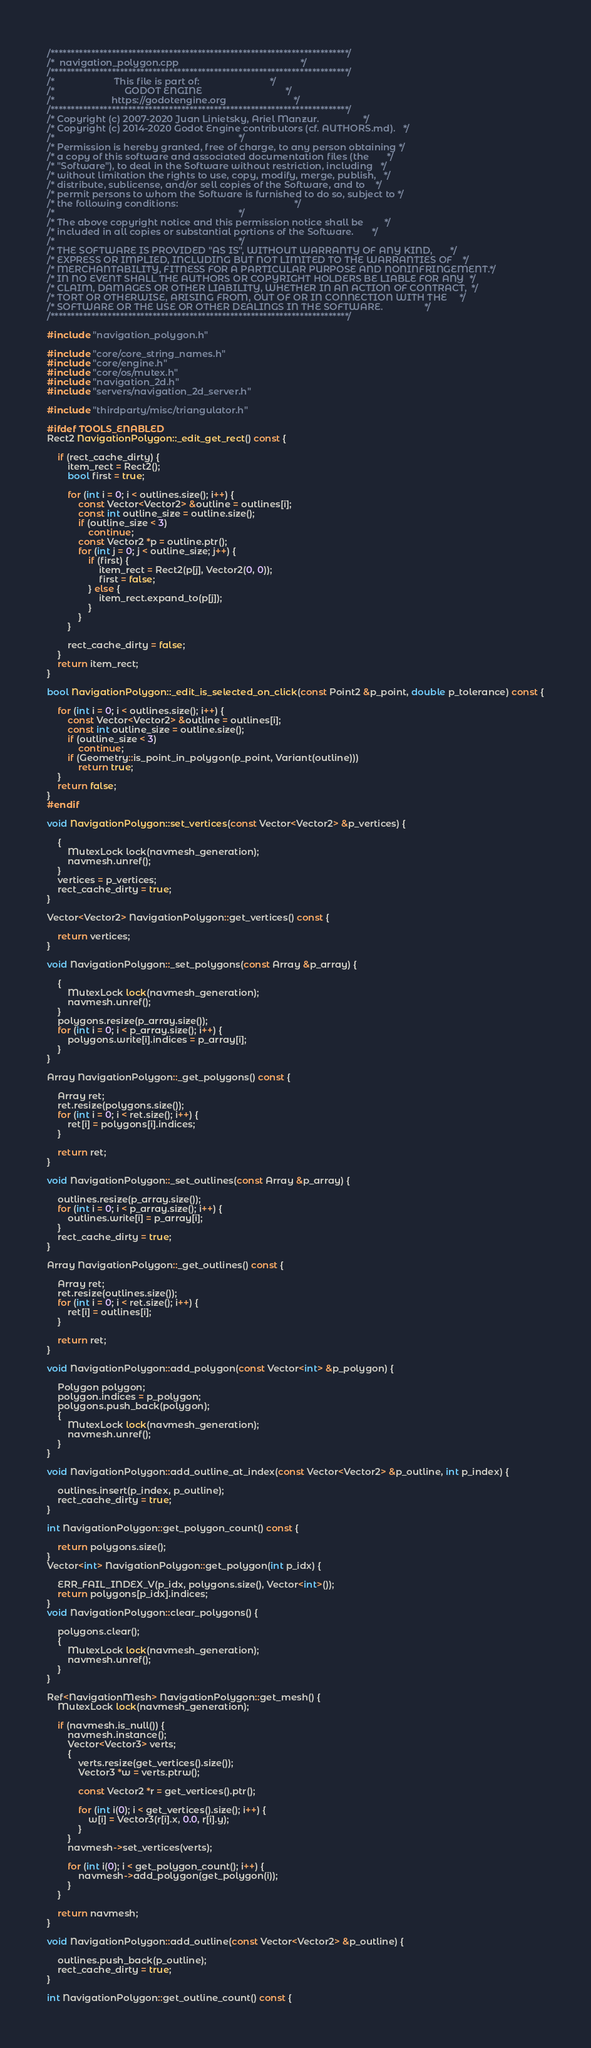<code> <loc_0><loc_0><loc_500><loc_500><_C++_>/*************************************************************************/
/*  navigation_polygon.cpp                                               */
/*************************************************************************/
/*                       This file is part of:                           */
/*                           GODOT ENGINE                                */
/*                      https://godotengine.org                          */
/*************************************************************************/
/* Copyright (c) 2007-2020 Juan Linietsky, Ariel Manzur.                 */
/* Copyright (c) 2014-2020 Godot Engine contributors (cf. AUTHORS.md).   */
/*                                                                       */
/* Permission is hereby granted, free of charge, to any person obtaining */
/* a copy of this software and associated documentation files (the       */
/* "Software"), to deal in the Software without restriction, including   */
/* without limitation the rights to use, copy, modify, merge, publish,   */
/* distribute, sublicense, and/or sell copies of the Software, and to    */
/* permit persons to whom the Software is furnished to do so, subject to */
/* the following conditions:                                             */
/*                                                                       */
/* The above copyright notice and this permission notice shall be        */
/* included in all copies or substantial portions of the Software.       */
/*                                                                       */
/* THE SOFTWARE IS PROVIDED "AS IS", WITHOUT WARRANTY OF ANY KIND,       */
/* EXPRESS OR IMPLIED, INCLUDING BUT NOT LIMITED TO THE WARRANTIES OF    */
/* MERCHANTABILITY, FITNESS FOR A PARTICULAR PURPOSE AND NONINFRINGEMENT.*/
/* IN NO EVENT SHALL THE AUTHORS OR COPYRIGHT HOLDERS BE LIABLE FOR ANY  */
/* CLAIM, DAMAGES OR OTHER LIABILITY, WHETHER IN AN ACTION OF CONTRACT,  */
/* TORT OR OTHERWISE, ARISING FROM, OUT OF OR IN CONNECTION WITH THE     */
/* SOFTWARE OR THE USE OR OTHER DEALINGS IN THE SOFTWARE.                */
/*************************************************************************/

#include "navigation_polygon.h"

#include "core/core_string_names.h"
#include "core/engine.h"
#include "core/os/mutex.h"
#include "navigation_2d.h"
#include "servers/navigation_2d_server.h"

#include "thirdparty/misc/triangulator.h"

#ifdef TOOLS_ENABLED
Rect2 NavigationPolygon::_edit_get_rect() const {

	if (rect_cache_dirty) {
		item_rect = Rect2();
		bool first = true;

		for (int i = 0; i < outlines.size(); i++) {
			const Vector<Vector2> &outline = outlines[i];
			const int outline_size = outline.size();
			if (outline_size < 3)
				continue;
			const Vector2 *p = outline.ptr();
			for (int j = 0; j < outline_size; j++) {
				if (first) {
					item_rect = Rect2(p[j], Vector2(0, 0));
					first = false;
				} else {
					item_rect.expand_to(p[j]);
				}
			}
		}

		rect_cache_dirty = false;
	}
	return item_rect;
}

bool NavigationPolygon::_edit_is_selected_on_click(const Point2 &p_point, double p_tolerance) const {

	for (int i = 0; i < outlines.size(); i++) {
		const Vector<Vector2> &outline = outlines[i];
		const int outline_size = outline.size();
		if (outline_size < 3)
			continue;
		if (Geometry::is_point_in_polygon(p_point, Variant(outline)))
			return true;
	}
	return false;
}
#endif

void NavigationPolygon::set_vertices(const Vector<Vector2> &p_vertices) {

	{
		MutexLock lock(navmesh_generation);
		navmesh.unref();
	}
	vertices = p_vertices;
	rect_cache_dirty = true;
}

Vector<Vector2> NavigationPolygon::get_vertices() const {

	return vertices;
}

void NavigationPolygon::_set_polygons(const Array &p_array) {

	{
		MutexLock lock(navmesh_generation);
		navmesh.unref();
	}
	polygons.resize(p_array.size());
	for (int i = 0; i < p_array.size(); i++) {
		polygons.write[i].indices = p_array[i];
	}
}

Array NavigationPolygon::_get_polygons() const {

	Array ret;
	ret.resize(polygons.size());
	for (int i = 0; i < ret.size(); i++) {
		ret[i] = polygons[i].indices;
	}

	return ret;
}

void NavigationPolygon::_set_outlines(const Array &p_array) {

	outlines.resize(p_array.size());
	for (int i = 0; i < p_array.size(); i++) {
		outlines.write[i] = p_array[i];
	}
	rect_cache_dirty = true;
}

Array NavigationPolygon::_get_outlines() const {

	Array ret;
	ret.resize(outlines.size());
	for (int i = 0; i < ret.size(); i++) {
		ret[i] = outlines[i];
	}

	return ret;
}

void NavigationPolygon::add_polygon(const Vector<int> &p_polygon) {

	Polygon polygon;
	polygon.indices = p_polygon;
	polygons.push_back(polygon);
	{
		MutexLock lock(navmesh_generation);
		navmesh.unref();
	}
}

void NavigationPolygon::add_outline_at_index(const Vector<Vector2> &p_outline, int p_index) {

	outlines.insert(p_index, p_outline);
	rect_cache_dirty = true;
}

int NavigationPolygon::get_polygon_count() const {

	return polygons.size();
}
Vector<int> NavigationPolygon::get_polygon(int p_idx) {

	ERR_FAIL_INDEX_V(p_idx, polygons.size(), Vector<int>());
	return polygons[p_idx].indices;
}
void NavigationPolygon::clear_polygons() {

	polygons.clear();
	{
		MutexLock lock(navmesh_generation);
		navmesh.unref();
	}
}

Ref<NavigationMesh> NavigationPolygon::get_mesh() {
	MutexLock lock(navmesh_generation);

	if (navmesh.is_null()) {
		navmesh.instance();
		Vector<Vector3> verts;
		{
			verts.resize(get_vertices().size());
			Vector3 *w = verts.ptrw();

			const Vector2 *r = get_vertices().ptr();

			for (int i(0); i < get_vertices().size(); i++) {
				w[i] = Vector3(r[i].x, 0.0, r[i].y);
			}
		}
		navmesh->set_vertices(verts);

		for (int i(0); i < get_polygon_count(); i++) {
			navmesh->add_polygon(get_polygon(i));
		}
	}

	return navmesh;
}

void NavigationPolygon::add_outline(const Vector<Vector2> &p_outline) {

	outlines.push_back(p_outline);
	rect_cache_dirty = true;
}

int NavigationPolygon::get_outline_count() const {
</code> 